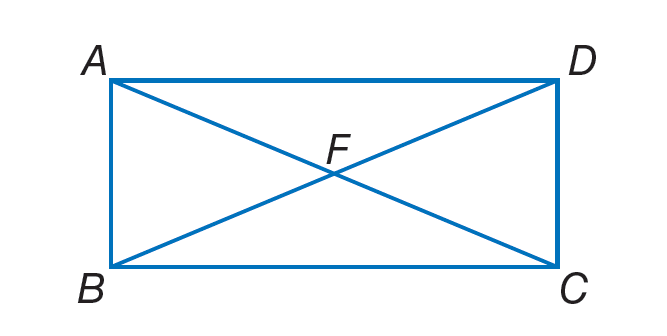Answer the mathemtical geometry problem and directly provide the correct option letter.
Question: Quadrilateral A B C D is a rectangle. If m \angle A D B = 4 x + 8 and m \angle D B A = 6 x + 12, find x.
Choices: A: 7 B: 20 C: 36 D: 54 A 